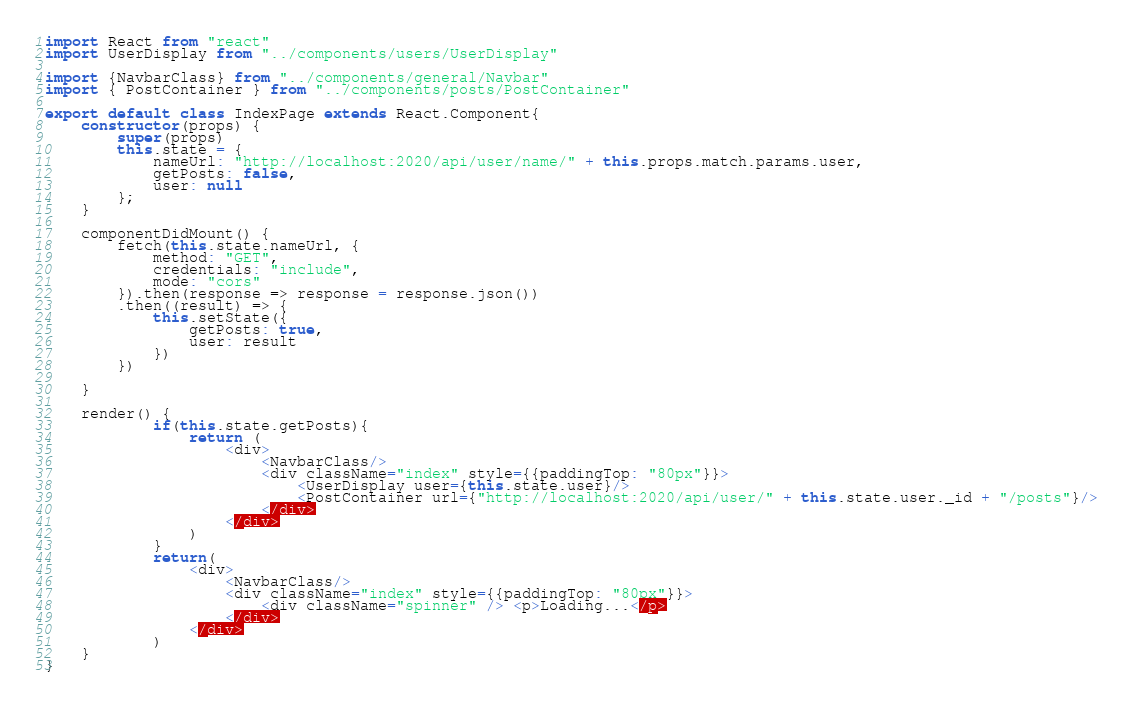<code> <loc_0><loc_0><loc_500><loc_500><_JavaScript_>import React from "react"
import UserDisplay from "../components/users/UserDisplay"

import {NavbarClass} from "../components/general/Navbar"
import { PostContainer } from "../components/posts/PostContainer"

export default class IndexPage extends React.Component{
    constructor(props) {
        super(props)
        this.state = {
            nameUrl: "http://localhost:2020/api/user/name/" + this.props.match.params.user,
            getPosts: false,
            user: null
        };
    }

    componentDidMount() {
        fetch(this.state.nameUrl, {
            method: "GET",
            credentials: "include",
            mode: "cors"
        }).then(response => response = response.json())
        .then((result) => {
            this.setState({
                getPosts: true, 
                user: result
            })
        })

    }

    render() {
            if(this.state.getPosts){
                return (
                    <div>
                        <NavbarClass/>
                        <div className="index" style={{paddingTop: "80px"}}>
                            <UserDisplay user={this.state.user}/>
                            <PostContainer url={"http://localhost:2020/api/user/" + this.state.user._id + "/posts"}/>
                        </div>
                    </div>
                )
            }
            return(
                <div>
                    <NavbarClass/>
                    <div className="index" style={{paddingTop: "80px"}}>
                        <div className="spinner" /> <p>Loading...</p>
                    </div>
                </div>
            )
    }
}
</code> 